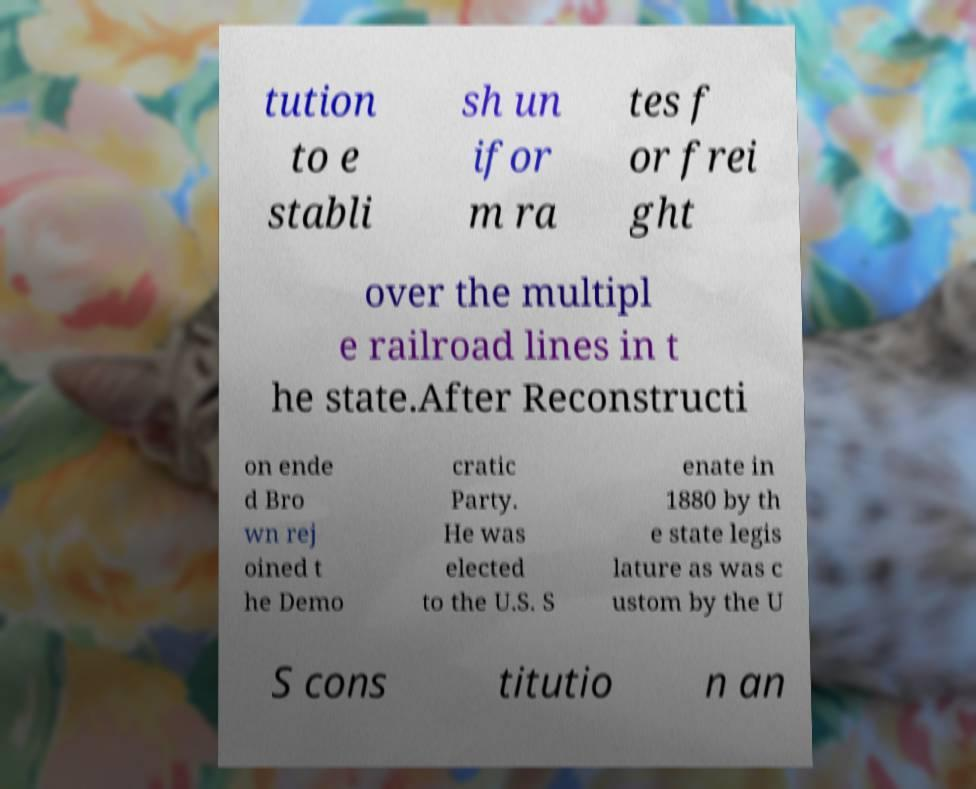Please identify and transcribe the text found in this image. tution to e stabli sh un ifor m ra tes f or frei ght over the multipl e railroad lines in t he state.After Reconstructi on ende d Bro wn rej oined t he Demo cratic Party. He was elected to the U.S. S enate in 1880 by th e state legis lature as was c ustom by the U S cons titutio n an 